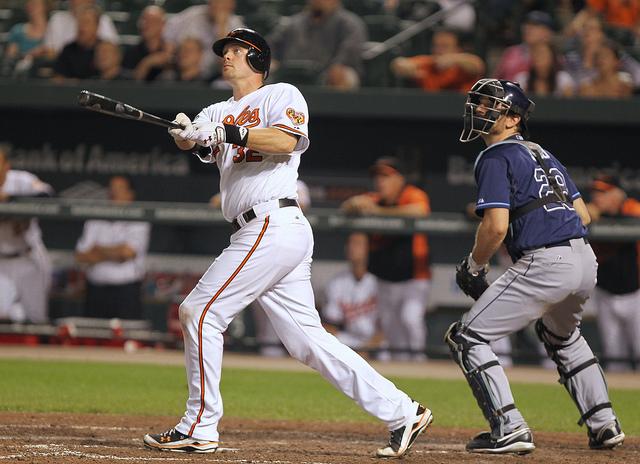What color are the grassy areas?
Give a very brief answer. Green. What is the batters jersey number?
Give a very brief answer. 32. What color is the catcher's shirt?
Concise answer only. Blue. 